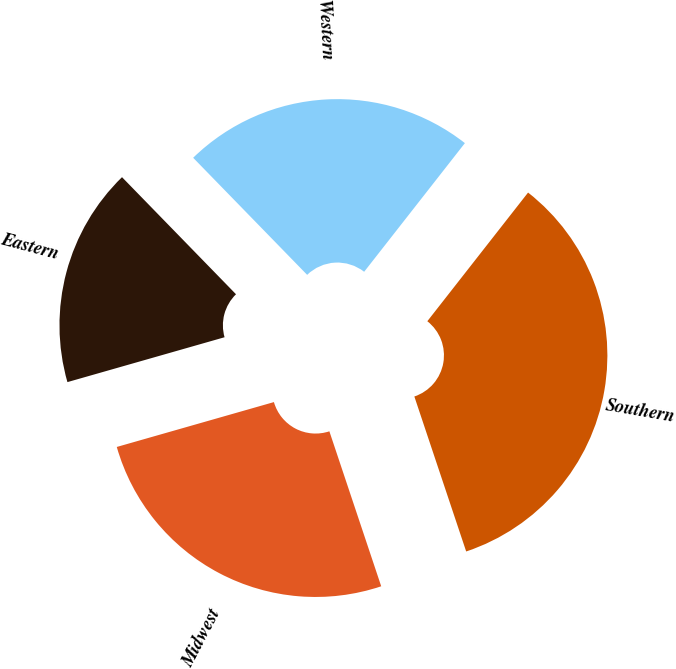Convert chart. <chart><loc_0><loc_0><loc_500><loc_500><pie_chart><fcel>Eastern<fcel>Midwest<fcel>Southern<fcel>Western<nl><fcel>17.14%<fcel>25.71%<fcel>34.29%<fcel>22.86%<nl></chart> 